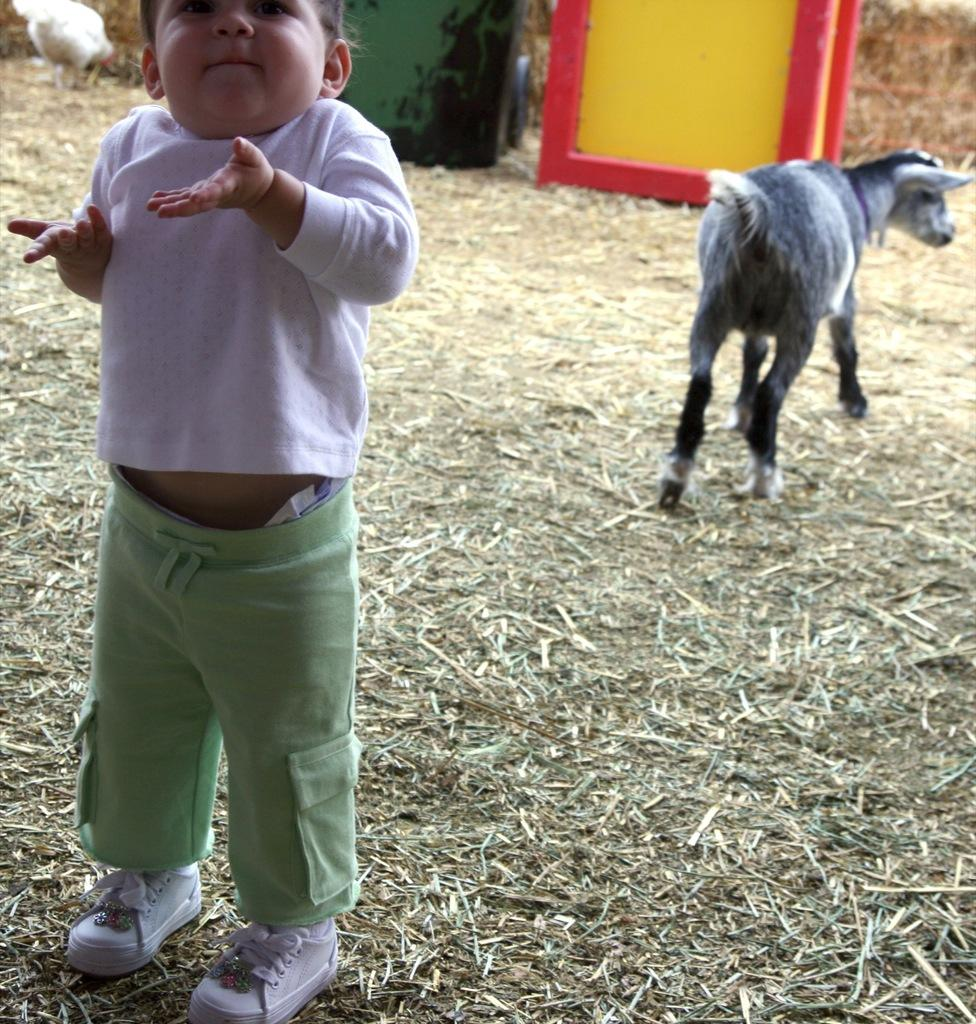What animal is present in the image? There is a goat in the image. Who else is present in the image? There is a boy in the image. What type of shoes is the boy wearing? The boy is wearing white shoes. What type of terrain is visible at the bottom of the image? There is grass at the bottom of the image. What type of sail can be seen in the image? There is no sail present in the image; it features a goat and a boy on grass. 